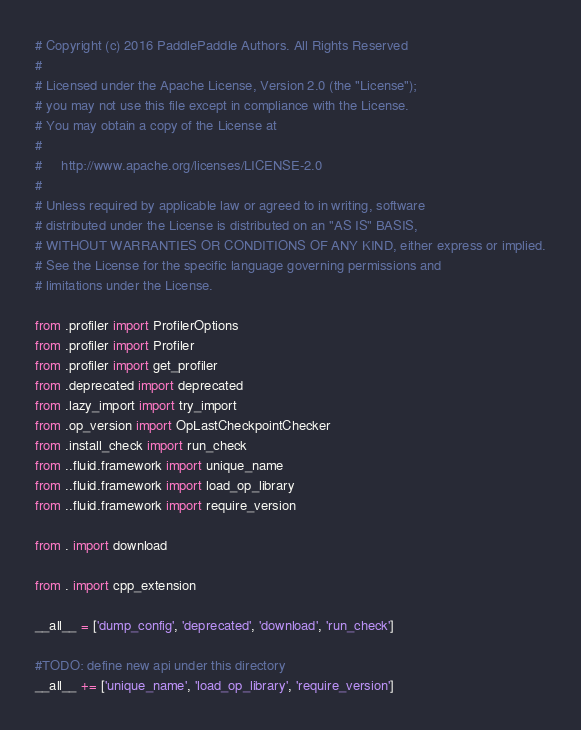<code> <loc_0><loc_0><loc_500><loc_500><_Python_># Copyright (c) 2016 PaddlePaddle Authors. All Rights Reserved
#
# Licensed under the Apache License, Version 2.0 (the "License");
# you may not use this file except in compliance with the License.
# You may obtain a copy of the License at
#
#     http://www.apache.org/licenses/LICENSE-2.0
#
# Unless required by applicable law or agreed to in writing, software
# distributed under the License is distributed on an "AS IS" BASIS,
# WITHOUT WARRANTIES OR CONDITIONS OF ANY KIND, either express or implied.
# See the License for the specific language governing permissions and
# limitations under the License.

from .profiler import ProfilerOptions
from .profiler import Profiler
from .profiler import get_profiler
from .deprecated import deprecated
from .lazy_import import try_import
from .op_version import OpLastCheckpointChecker
from .install_check import run_check
from ..fluid.framework import unique_name
from ..fluid.framework import load_op_library
from ..fluid.framework import require_version

from . import download

from . import cpp_extension

__all__ = ['dump_config', 'deprecated', 'download', 'run_check']

#TODO: define new api under this directory
__all__ += ['unique_name', 'load_op_library', 'require_version']
</code> 